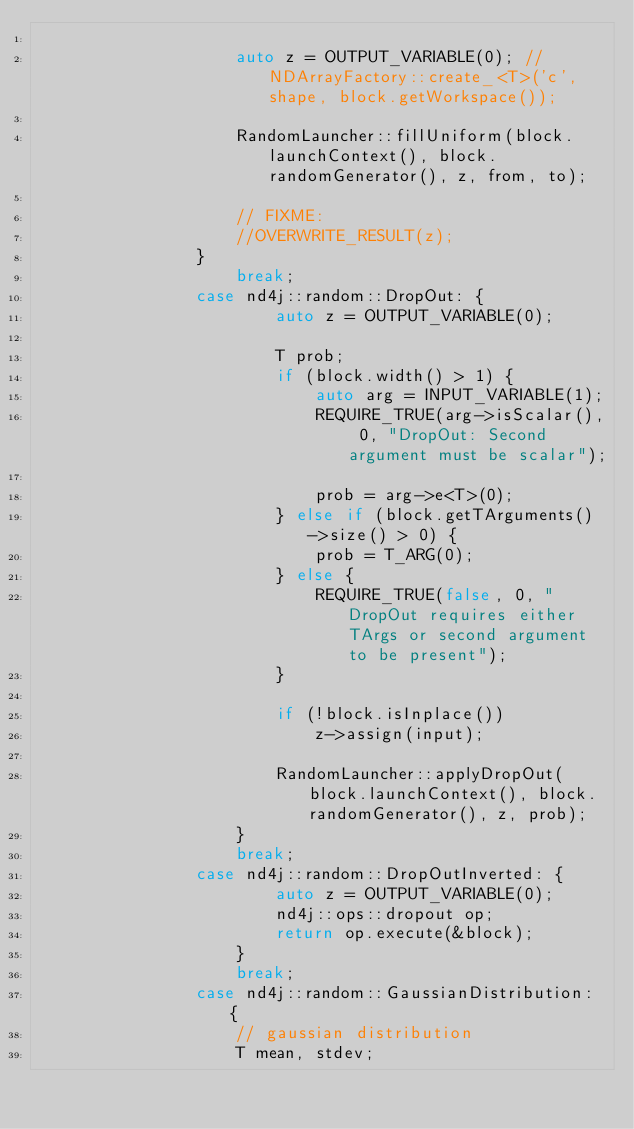<code> <loc_0><loc_0><loc_500><loc_500><_C++_>
                    auto z = OUTPUT_VARIABLE(0); //NDArrayFactory::create_<T>('c', shape, block.getWorkspace());

                    RandomLauncher::fillUniform(block.launchContext(), block.randomGenerator(), z, from, to);

                    // FIXME:
                    //OVERWRITE_RESULT(z);
                }
                    break;
                case nd4j::random::DropOut: {
                        auto z = OUTPUT_VARIABLE(0);

                        T prob;
                        if (block.width() > 1) {
                            auto arg = INPUT_VARIABLE(1);
                            REQUIRE_TRUE(arg->isScalar(), 0, "DropOut: Second argument must be scalar");

                            prob = arg->e<T>(0);
                        } else if (block.getTArguments()->size() > 0) {
                            prob = T_ARG(0);
                        } else {
                            REQUIRE_TRUE(false, 0, "DropOut requires either TArgs or second argument to be present");
                        }

                        if (!block.isInplace())
                            z->assign(input);

                        RandomLauncher::applyDropOut(block.launchContext(), block.randomGenerator(), z, prob);
                    }
                    break;
                case nd4j::random::DropOutInverted: {
                        auto z = OUTPUT_VARIABLE(0);
                        nd4j::ops::dropout op;
                        return op.execute(&block);
                    }
                    break;
                case nd4j::random::GaussianDistribution: {
                    // gaussian distribution
                    T mean, stdev;</code> 